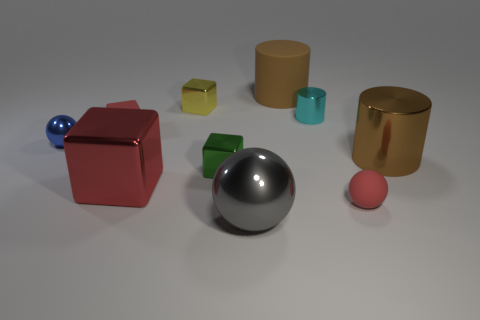Subtract all brown cubes. Subtract all green cylinders. How many cubes are left? 4 Subtract all cylinders. How many objects are left? 7 Add 1 tiny purple rubber cubes. How many tiny purple rubber cubes exist? 1 Subtract 0 yellow cylinders. How many objects are left? 10 Subtract all big metallic cubes. Subtract all tiny green shiny blocks. How many objects are left? 8 Add 1 yellow shiny things. How many yellow shiny things are left? 2 